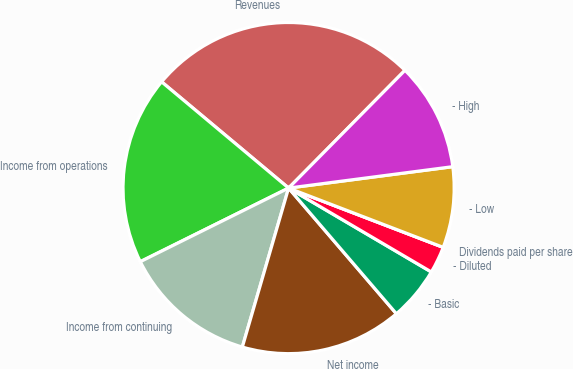Convert chart to OTSL. <chart><loc_0><loc_0><loc_500><loc_500><pie_chart><fcel>Revenues<fcel>Income from operations<fcel>Income from continuing<fcel>Net income<fcel>- Basic<fcel>- Diluted<fcel>Dividends paid per share<fcel>- Low<fcel>- High<nl><fcel>26.32%<fcel>18.42%<fcel>13.16%<fcel>15.79%<fcel>5.26%<fcel>2.63%<fcel>0.0%<fcel>7.89%<fcel>10.53%<nl></chart> 